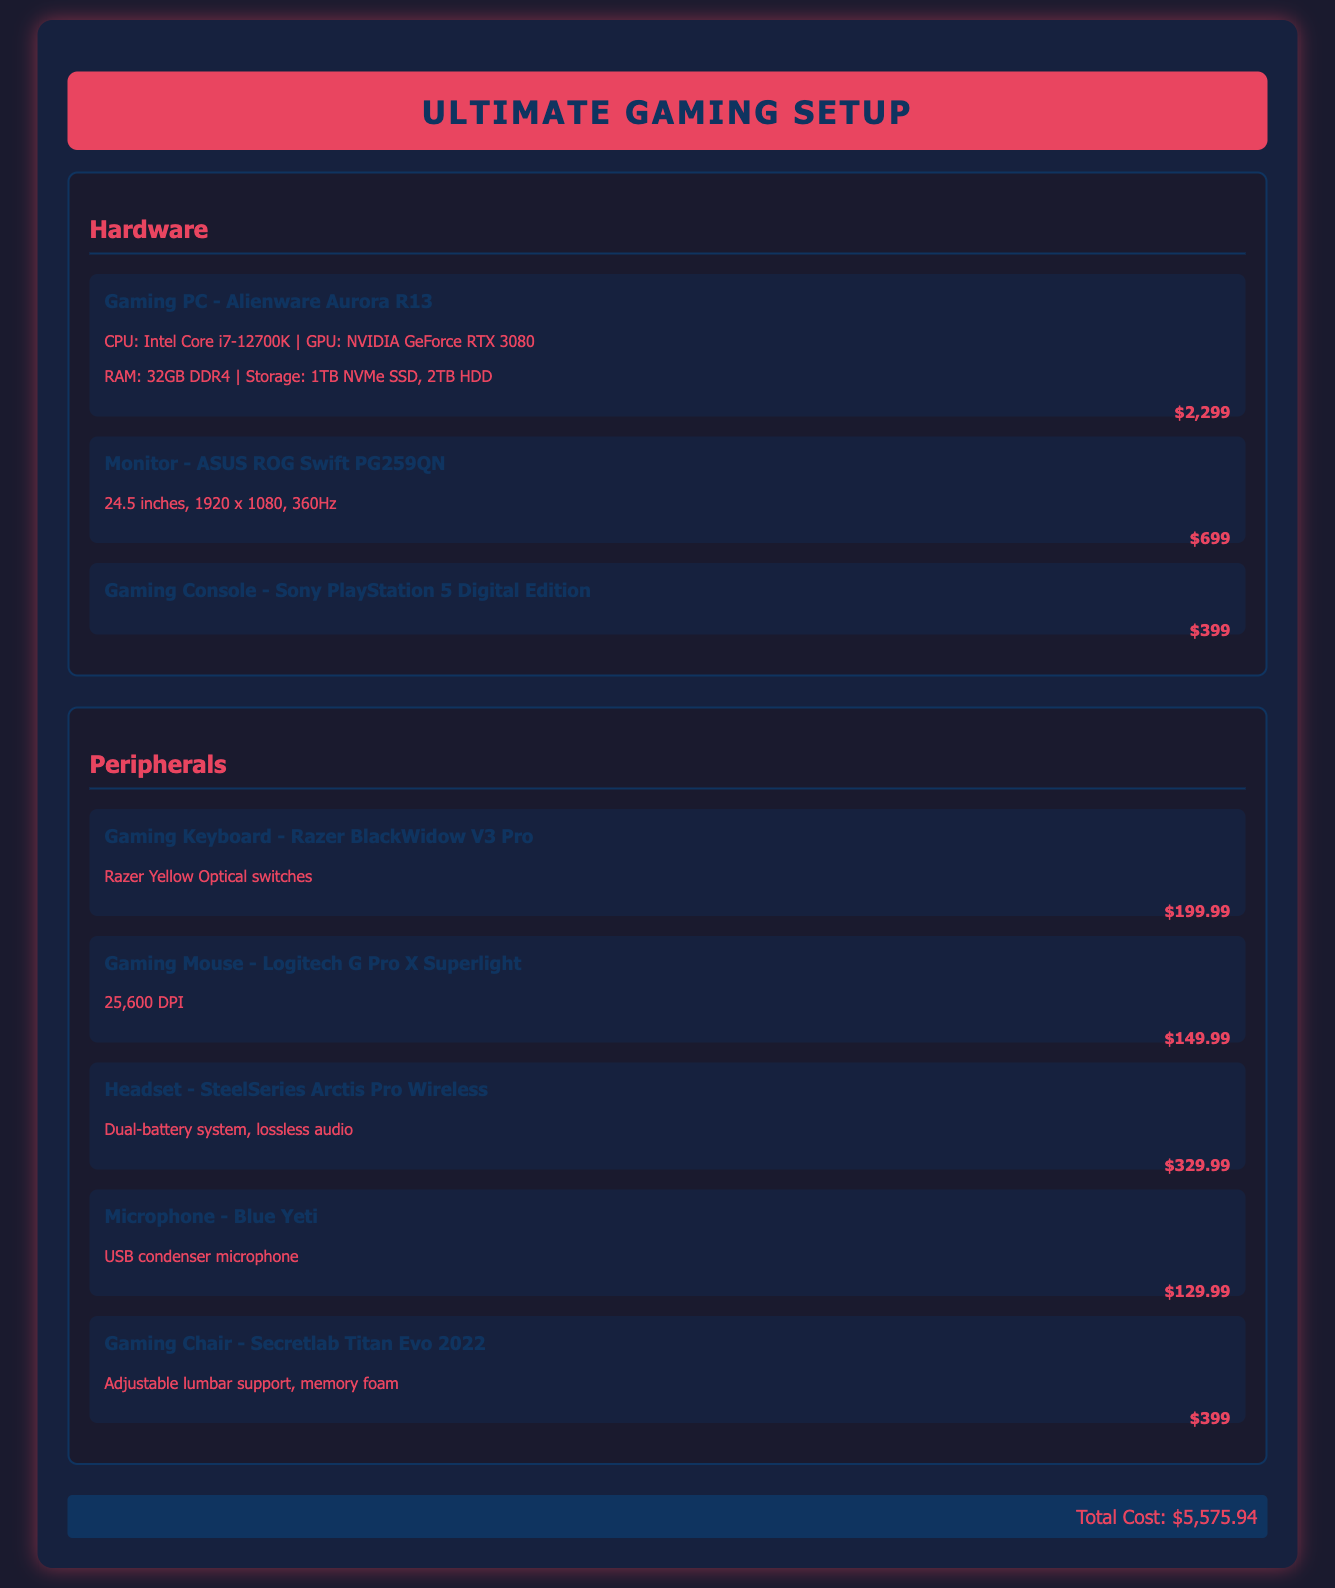What is the total cost of the gaming setup? The total cost is stated at the bottom of the document, summing all items listed.
Answer: $5,575.94 What type of CPU does the gaming PC have? The document specifies the CPU type directly in the hardware section under the gaming PC item.
Answer: Intel Core i7-12700K How many inches is the monitor? The monitor section provides the size of the monitor in inches.
Answer: 24.5 inches What brand is the gaming chair? The document mentions the brand of the gaming chair in the peripherals section.
Answer: Secretlab Which GPU is included in the gaming PC? The GPU information is included in the description of the gaming PC in the hardware section.
Answer: NVIDIA GeForce RTX 3080 How much does the gaming mouse cost? The price for the gaming mouse is listed directly in the peripherals section.
Answer: $149.99 What type of switches does the gaming keyboard use? The document describes the keyboard's switch type in its item description.
Answer: Razer Yellow Optical switches Which device has a dual-battery system? The specification mentions this unique feature in the headset item's description.
Answer: SteelSeries Arctis Pro Wireless What is the monitor's refresh rate? The document provides the refresh rate in the specifications for the monitor.
Answer: 360Hz 